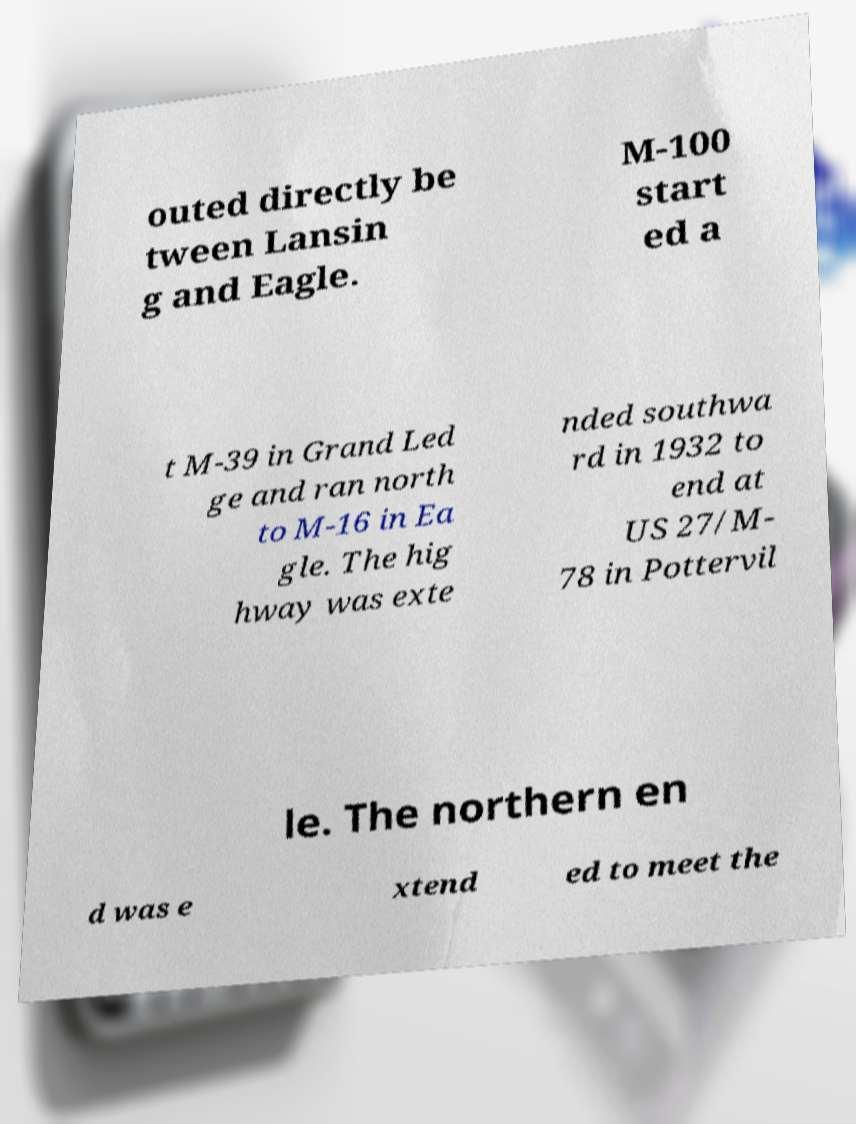Can you accurately transcribe the text from the provided image for me? outed directly be tween Lansin g and Eagle. M-100 start ed a t M-39 in Grand Led ge and ran north to M-16 in Ea gle. The hig hway was exte nded southwa rd in 1932 to end at US 27/M- 78 in Pottervil le. The northern en d was e xtend ed to meet the 